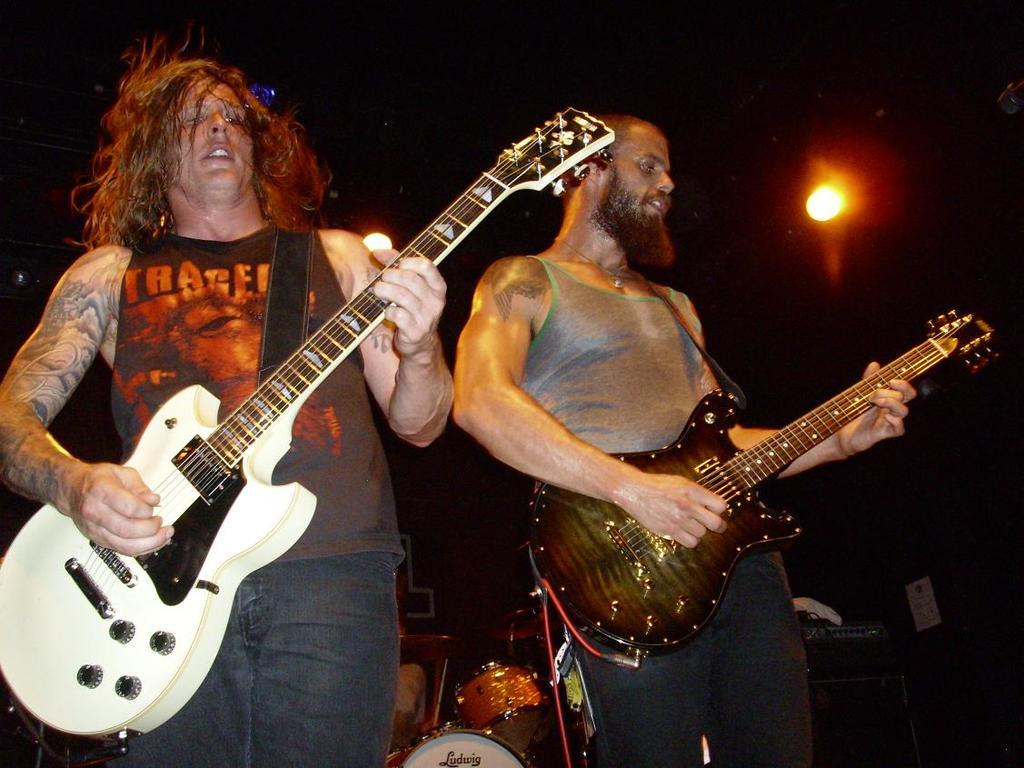How many people are in the image? There are two people in the image. What are the two people doing in the image? The two people are playing guitar. What other musical instruments can be seen in the image? There are other musical instruments visible in the image. What is the color of the background in the image? The background of the image is dark. Can you describe the lighting in the image? There is a light in the image. What type of weather can be seen in the image? There is no weather visible in the image, as it is focused on the people playing musical instruments. Can you tell me what card game the people are playing in the image? There is no card game present in the image; the people are playing musical instruments. 